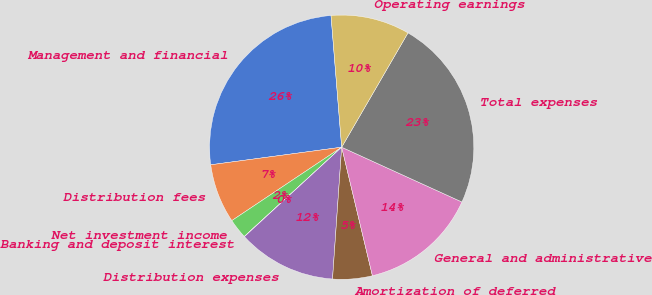Convert chart to OTSL. <chart><loc_0><loc_0><loc_500><loc_500><pie_chart><fcel>Management and financial<fcel>Distribution fees<fcel>Net investment income<fcel>Banking and deposit interest<fcel>Distribution expenses<fcel>Amortization of deferred<fcel>General and administrative<fcel>Total expenses<fcel>Operating earnings<nl><fcel>25.84%<fcel>7.25%<fcel>2.43%<fcel>0.03%<fcel>12.06%<fcel>4.84%<fcel>14.46%<fcel>23.44%<fcel>9.65%<nl></chart> 